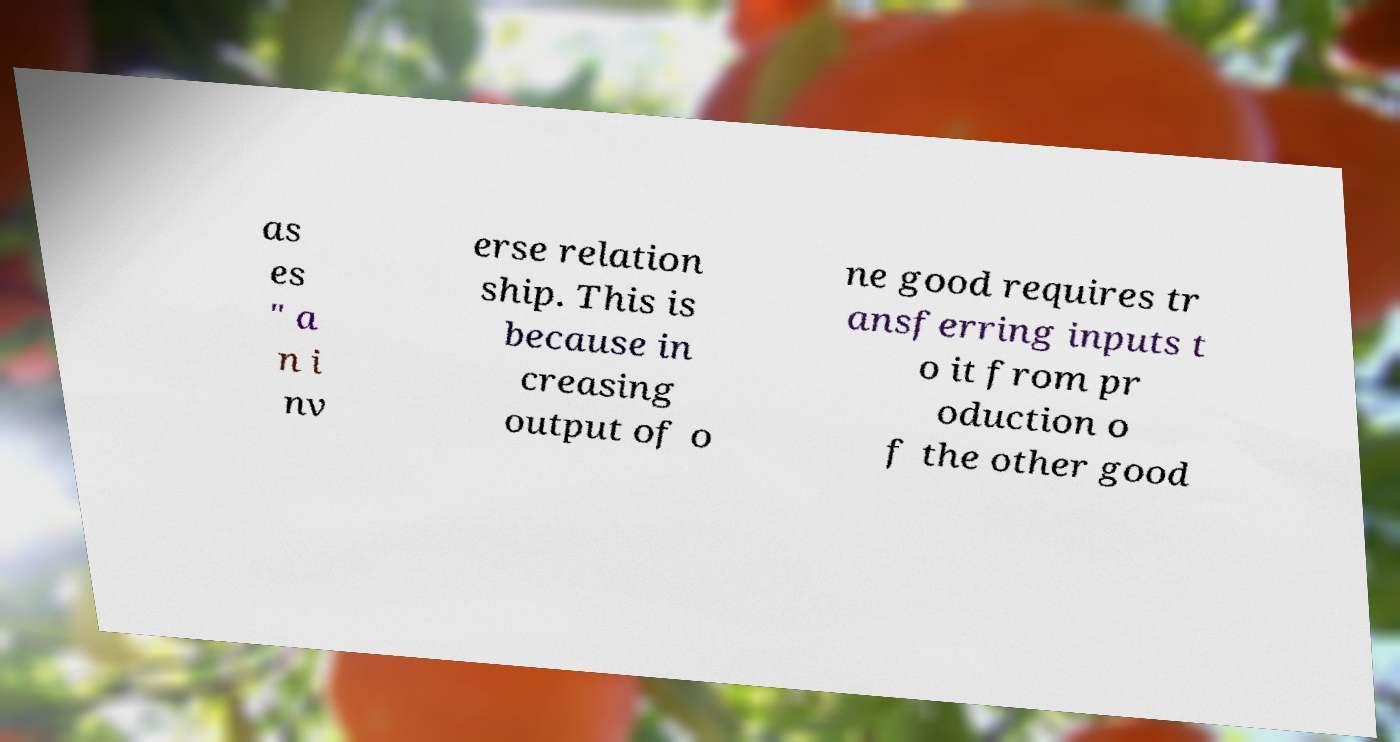For documentation purposes, I need the text within this image transcribed. Could you provide that? as es " a n i nv erse relation ship. This is because in creasing output of o ne good requires tr ansferring inputs t o it from pr oduction o f the other good 